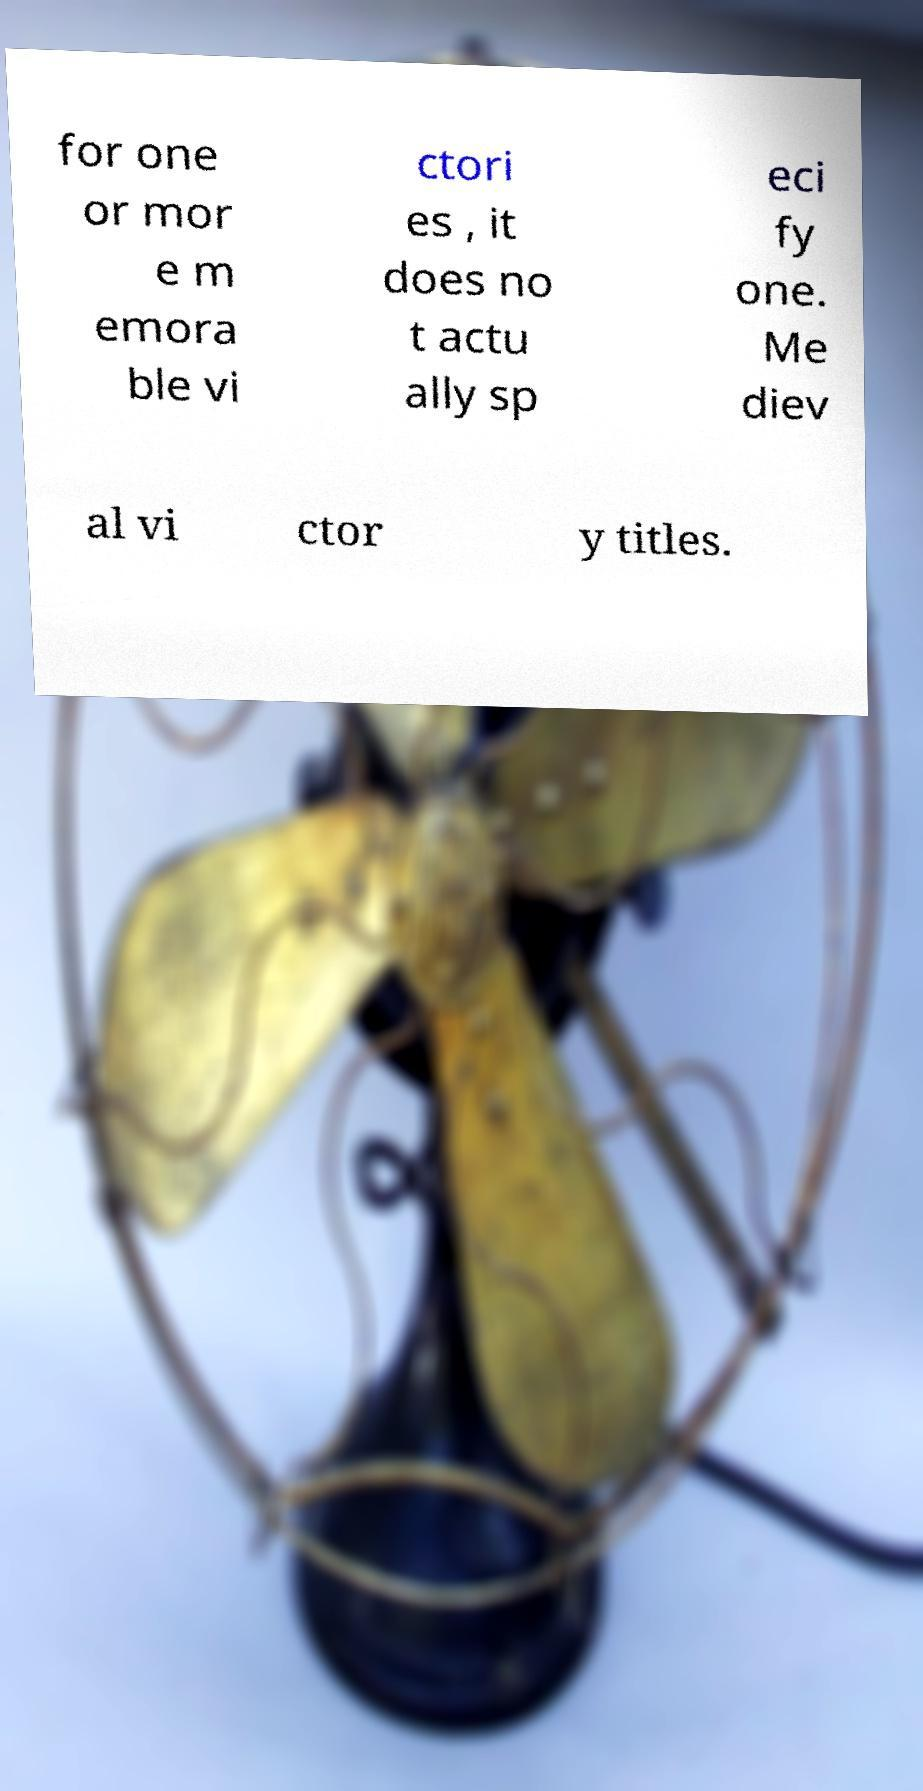Could you assist in decoding the text presented in this image and type it out clearly? for one or mor e m emora ble vi ctori es , it does no t actu ally sp eci fy one. Me diev al vi ctor y titles. 